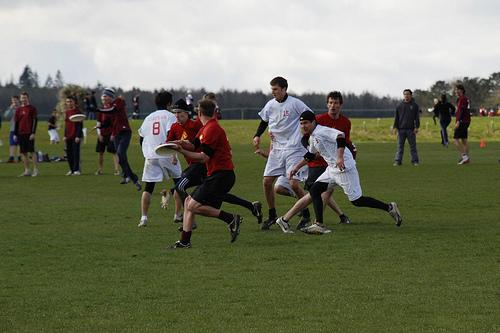Describe the setting of the image, including the landscape and weather. The frisbee match is taking place on a well-manicured grassy field, with trees in the background and a cool, cloudy sky above. Describe the attire of the players and mention a key element related to the sport. Players wear white and red uniforms with numbers, black elbow pads, and spiked shoes. A white frisbee is flying in the air. Identify the activity in the image and mention the teams involved. Two frisbee teams are playing against each other on the field, both wearing white and red uniforms. Highlight an interesting aspect of the landscape or weather in the photograph.  A beautiful view of green ground, framed by a cool-looking sky with clouds, dominating the background of the image. Mention the role of an object on the field and how it contributes to the scene. The orange boundary cone marks the field limits and adds a pop of color to the grassy landscape where the frisbee game unfolds. Provide a brief overview of the main elements in the picture. A group of people in white and red uniforms playing frisbee on a green field, with a vibrant sky in the background and an orange cone marking the boundary. Describe the interaction between players on the field. The frisbee players are in action, running and maneuvering with their teammates to catch and throw the white frisbee in the air. Comment on the condition of the field and how it might affect the game. The grass is well-manicured, providing an ideal surface for the frisbee match taking place between the two teams. 